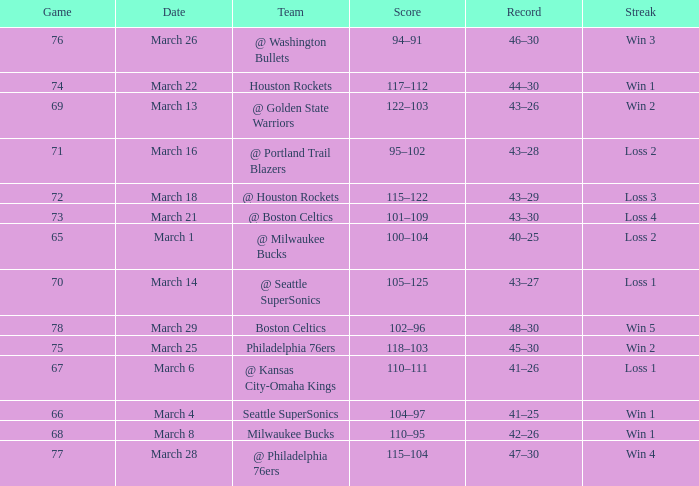Would you be able to parse every entry in this table? {'header': ['Game', 'Date', 'Team', 'Score', 'Record', 'Streak'], 'rows': [['76', 'March 26', '@ Washington Bullets', '94–91', '46–30', 'Win 3'], ['74', 'March 22', 'Houston Rockets', '117–112', '44–30', 'Win 1'], ['69', 'March 13', '@ Golden State Warriors', '122–103', '43–26', 'Win 2'], ['71', 'March 16', '@ Portland Trail Blazers', '95–102', '43–28', 'Loss 2'], ['72', 'March 18', '@ Houston Rockets', '115–122', '43–29', 'Loss 3'], ['73', 'March 21', '@ Boston Celtics', '101–109', '43–30', 'Loss 4'], ['65', 'March 1', '@ Milwaukee Bucks', '100–104', '40–25', 'Loss 2'], ['70', 'March 14', '@ Seattle SuperSonics', '105–125', '43–27', 'Loss 1'], ['78', 'March 29', 'Boston Celtics', '102–96', '48–30', 'Win 5'], ['75', 'March 25', 'Philadelphia 76ers', '118–103', '45–30', 'Win 2'], ['67', 'March 6', '@ Kansas City-Omaha Kings', '110–111', '41–26', 'Loss 1'], ['66', 'March 4', 'Seattle SuperSonics', '104–97', '41–25', 'Win 1'], ['68', 'March 8', 'Milwaukee Bucks', '110–95', '42–26', 'Win 1'], ['77', 'March 28', '@ Philadelphia 76ers', '115–104', '47–30', 'Win 4']]} What is the lowest Game, when Date is March 21? 73.0. 